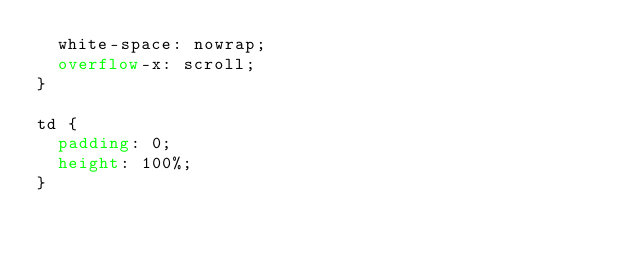<code> <loc_0><loc_0><loc_500><loc_500><_CSS_>  white-space: nowrap;
  overflow-x: scroll;
}

td {
  padding: 0;
  height: 100%;
}
</code> 